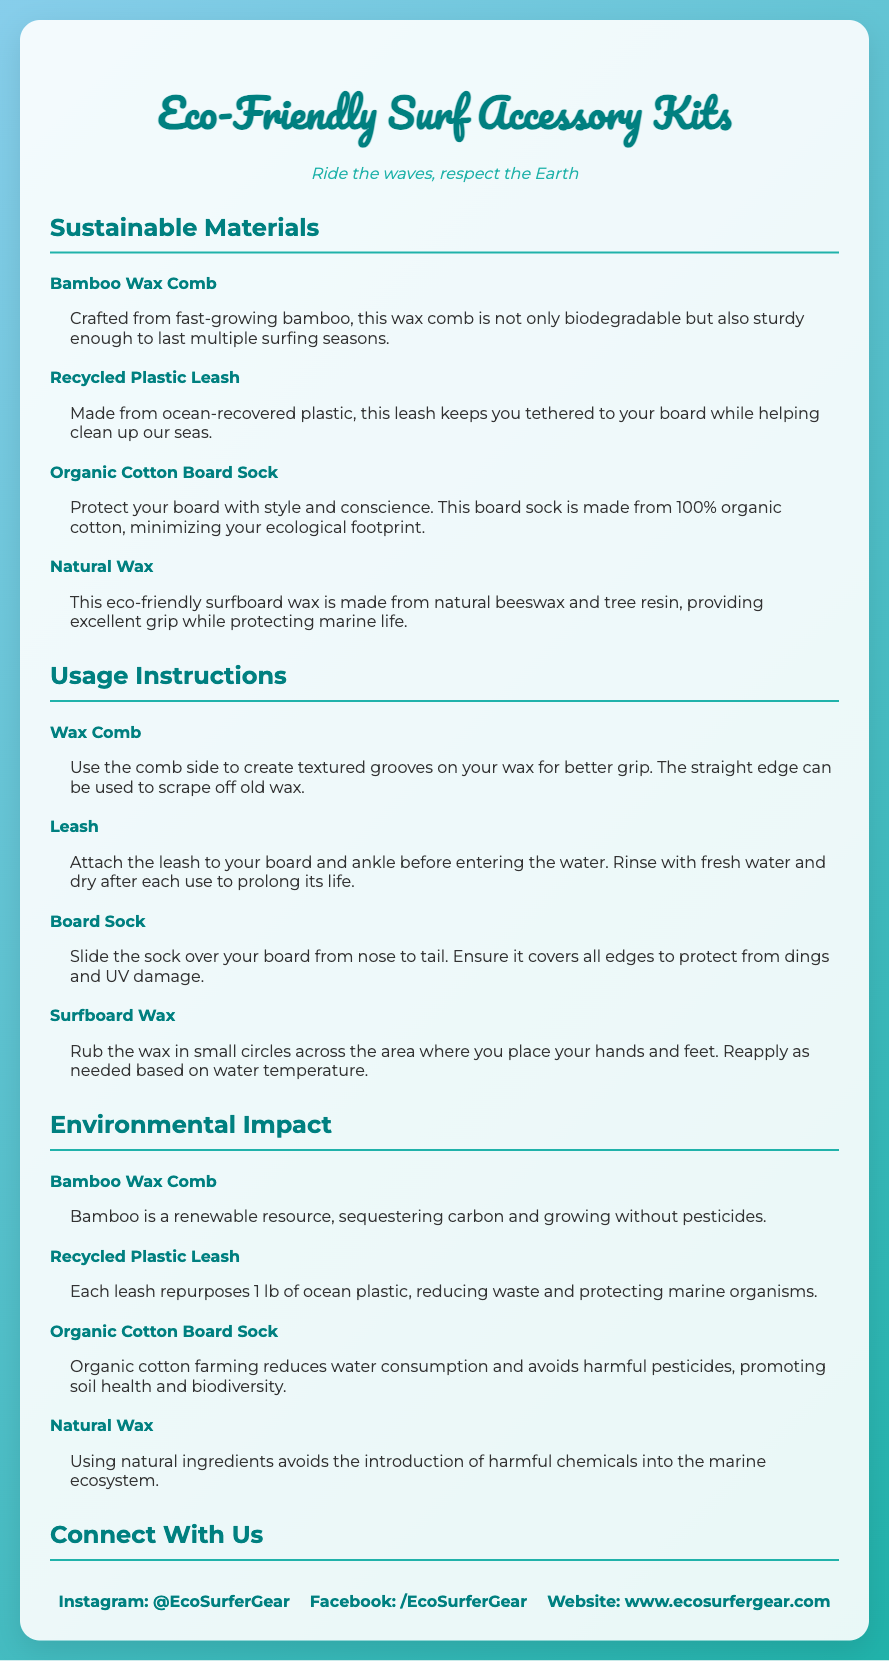what is the tagline of the product packaging? The tagline is a phrase that summarizes the essence of the product and is located right below the title, which is "Ride the waves, respect the Earth."
Answer: Ride the waves, respect the Earth how many sustainable materials are highlighted in the document? The document lists four sustainable materials under the section "Sustainable Materials," which include the Bamboo Wax Comb, Recycled Plastic Leash, Organic Cotton Board Sock, and Natural Wax.
Answer: 4 what should you use the wax comb for? The instructions specify that the comb can create textured grooves on the wax for better grip and also scrape off old wax, making it easy to find out its usage.
Answer: Create textured grooves and scrape off old wax what type of material is the board sock made of? The board sock is mentioned to be made from 100% organic cotton, which is highlighted as minimizing ecological footprint.
Answer: 100% organic cotton what is the main environmental benefit of using the recycled plastic leash? The environmental impact section describes that each leash repurposes 1 lb of ocean plastic, which reduces waste and protects marine organisms.
Answer: Repurposes 1 lb of ocean plastic what are the usage instructions for the leash? The document clearly states that the leash should be attached to the board and ankle before entering the water and recommends rinsing it with fresh water afterwards.
Answer: Attach to board and ankle; rinse with fresh water which brand's social media links are provided in the document? The social media links refer collectively to the same brand, indicated throughout the document, which is Eco Surfer Gear.
Answer: Eco Surfer Gear what is the purpose of natural wax in this kit? The natural wax is stated to provide excellent grip while protecting marine life, emphasizing both functionality and environmental consciousness.
Answer: Protects marine life and provides grip 